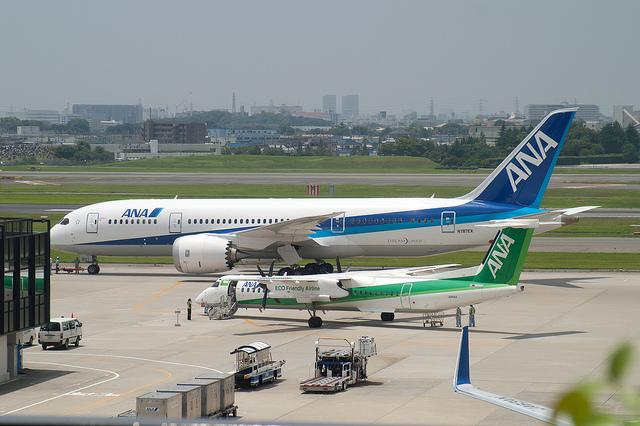Which vehicle can carry the most volume of supplies? blue plane 